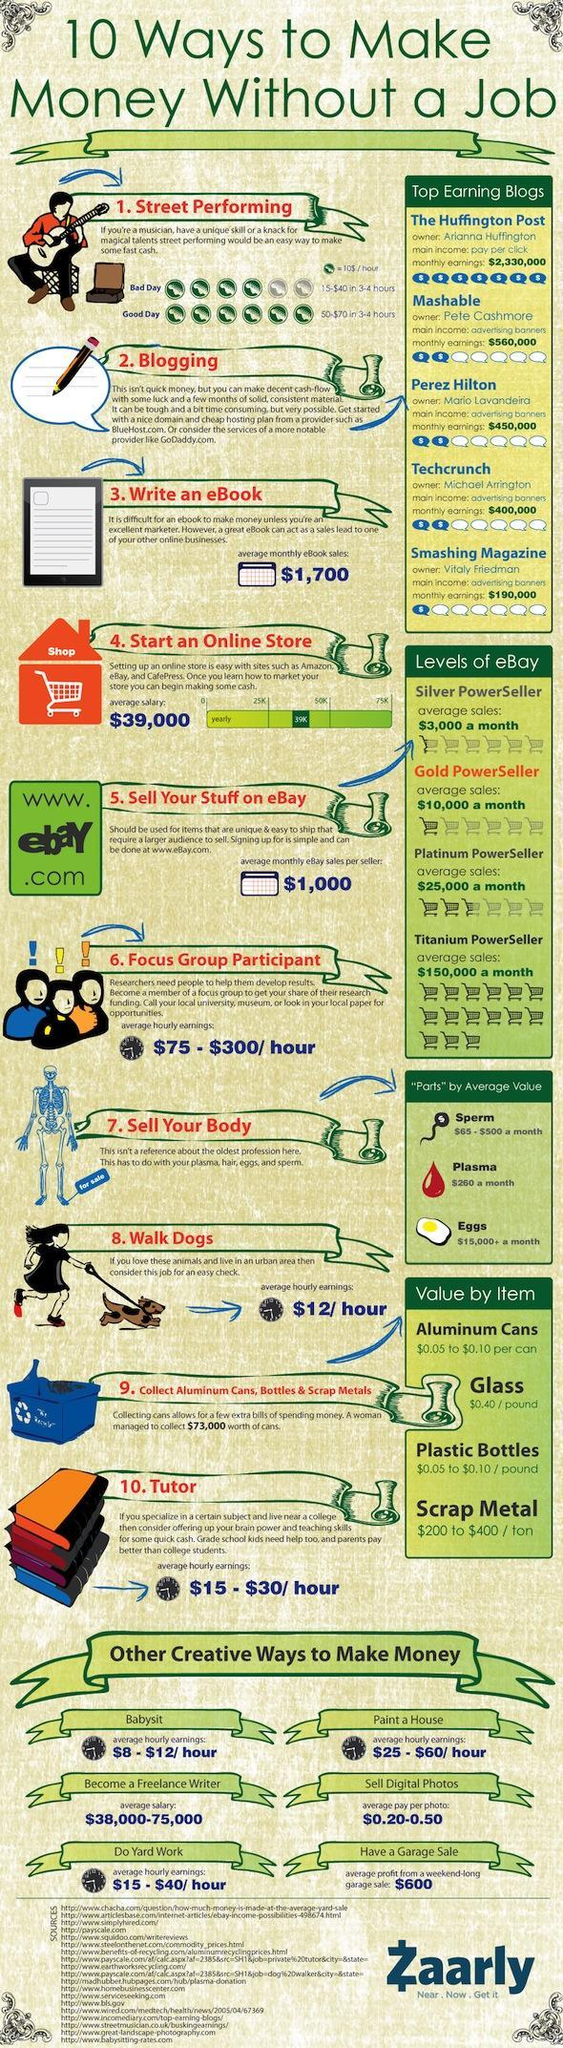Which blog receives highest monthly earnings through advertising banners?
Answer the question with a short phrase. Mashable Which body parts will fetch the most amount of money? Eggs 